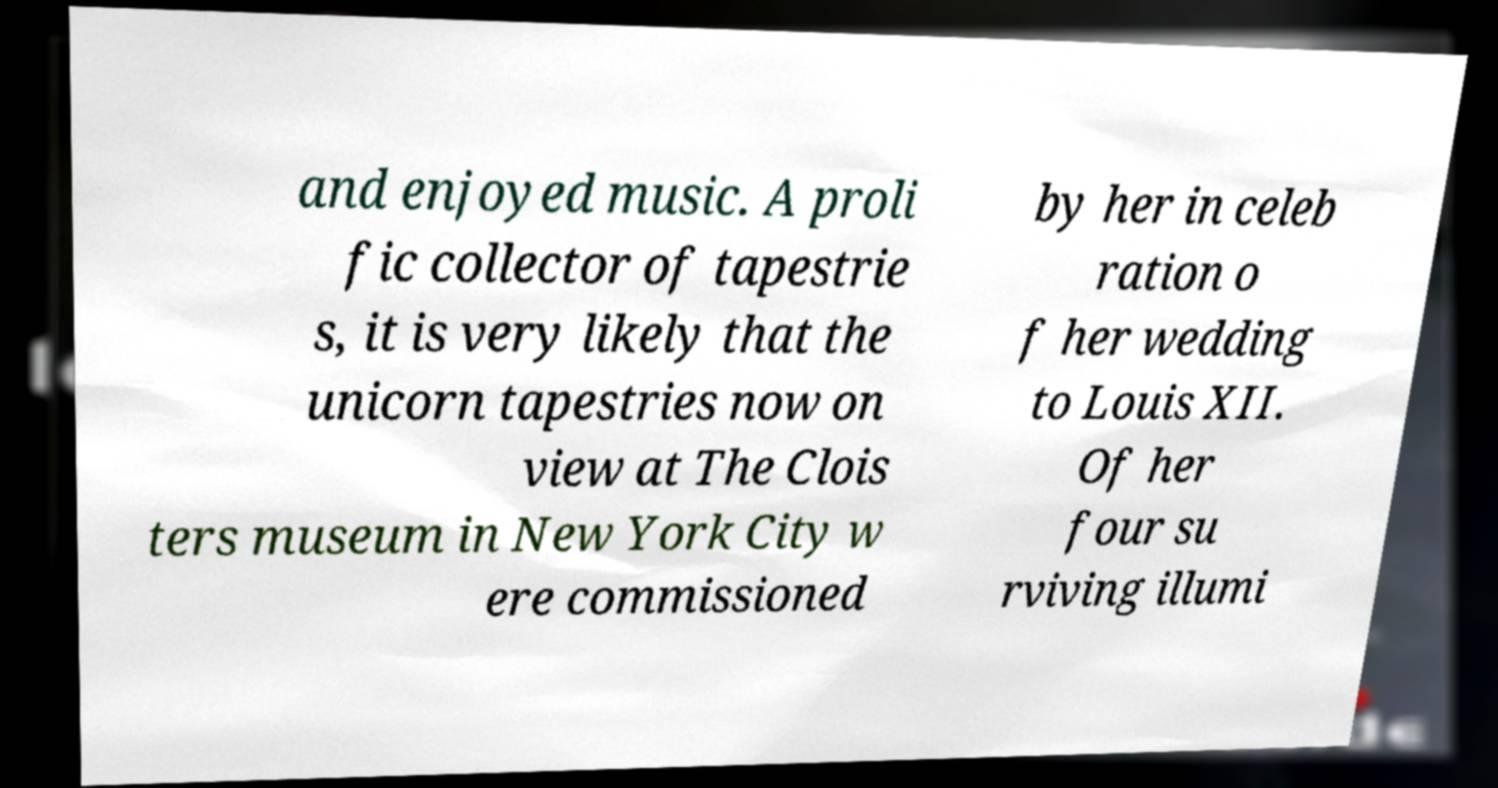Can you accurately transcribe the text from the provided image for me? and enjoyed music. A proli fic collector of tapestrie s, it is very likely that the unicorn tapestries now on view at The Clois ters museum in New York City w ere commissioned by her in celeb ration o f her wedding to Louis XII. Of her four su rviving illumi 